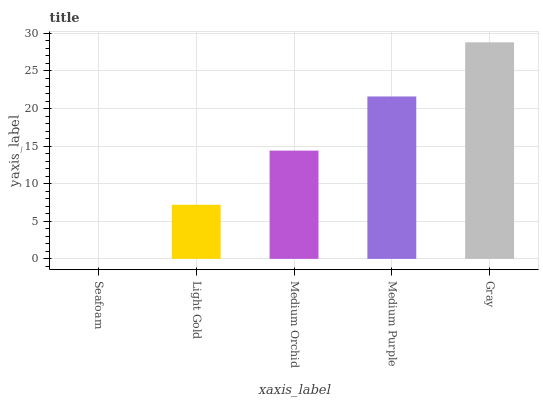Is Seafoam the minimum?
Answer yes or no. Yes. Is Gray the maximum?
Answer yes or no. Yes. Is Light Gold the minimum?
Answer yes or no. No. Is Light Gold the maximum?
Answer yes or no. No. Is Light Gold greater than Seafoam?
Answer yes or no. Yes. Is Seafoam less than Light Gold?
Answer yes or no. Yes. Is Seafoam greater than Light Gold?
Answer yes or no. No. Is Light Gold less than Seafoam?
Answer yes or no. No. Is Medium Orchid the high median?
Answer yes or no. Yes. Is Medium Orchid the low median?
Answer yes or no. Yes. Is Light Gold the high median?
Answer yes or no. No. Is Light Gold the low median?
Answer yes or no. No. 